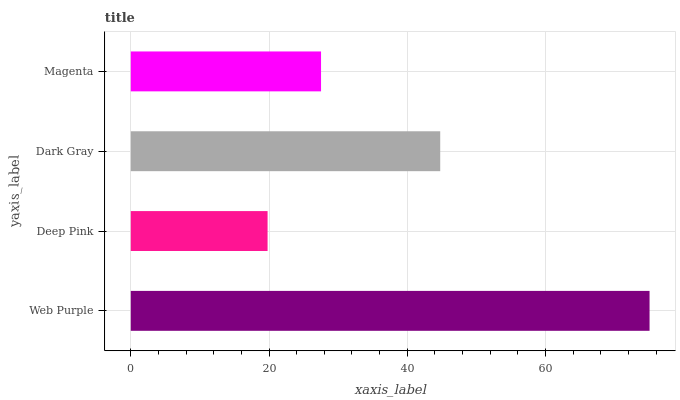Is Deep Pink the minimum?
Answer yes or no. Yes. Is Web Purple the maximum?
Answer yes or no. Yes. Is Dark Gray the minimum?
Answer yes or no. No. Is Dark Gray the maximum?
Answer yes or no. No. Is Dark Gray greater than Deep Pink?
Answer yes or no. Yes. Is Deep Pink less than Dark Gray?
Answer yes or no. Yes. Is Deep Pink greater than Dark Gray?
Answer yes or no. No. Is Dark Gray less than Deep Pink?
Answer yes or no. No. Is Dark Gray the high median?
Answer yes or no. Yes. Is Magenta the low median?
Answer yes or no. Yes. Is Web Purple the high median?
Answer yes or no. No. Is Deep Pink the low median?
Answer yes or no. No. 